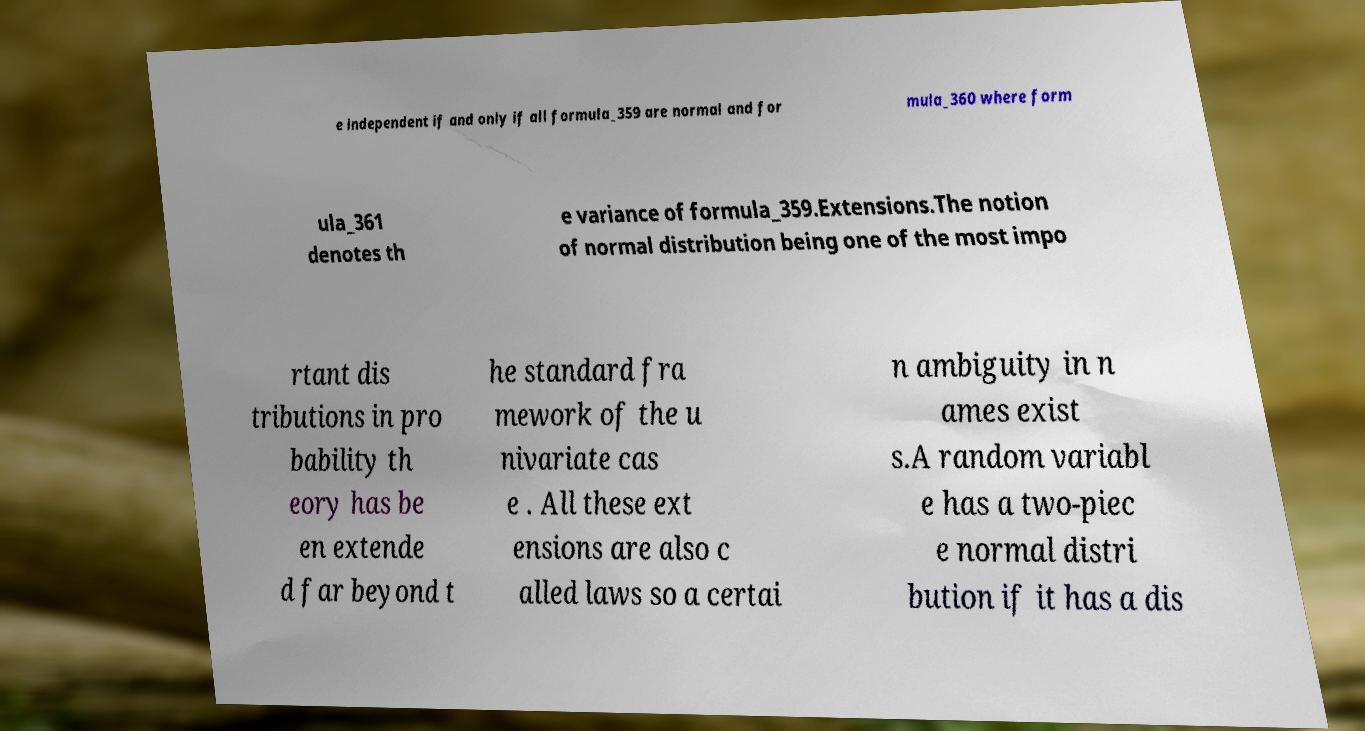For documentation purposes, I need the text within this image transcribed. Could you provide that? e independent if and only if all formula_359 are normal and for mula_360 where form ula_361 denotes th e variance of formula_359.Extensions.The notion of normal distribution being one of the most impo rtant dis tributions in pro bability th eory has be en extende d far beyond t he standard fra mework of the u nivariate cas e . All these ext ensions are also c alled laws so a certai n ambiguity in n ames exist s.A random variabl e has a two-piec e normal distri bution if it has a dis 